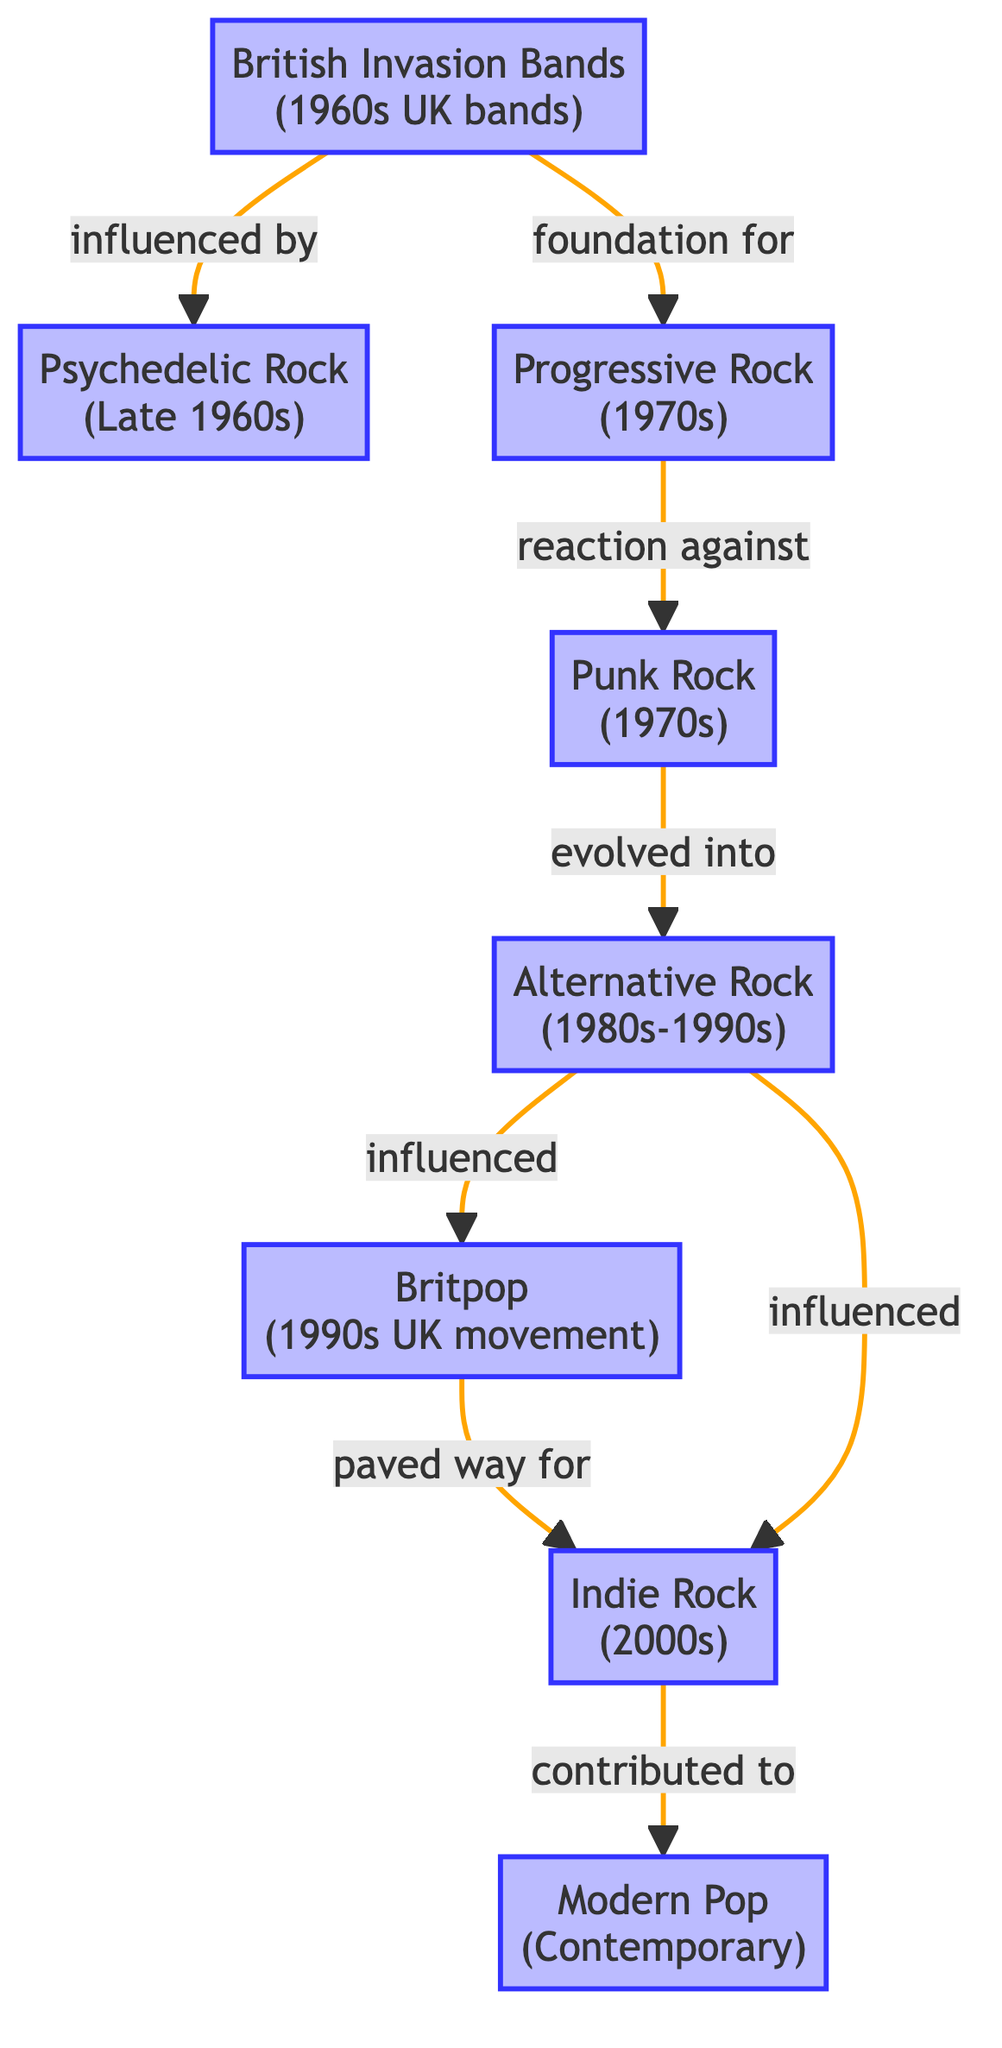What is the first node in the food chain? The first node in the food chain is "British Invasion Bands (1960s UK bands)," which serves as the starting point for the flow of popularity in this diagram.
Answer: British Invasion Bands (1960s UK bands) How many nodes are in the food chain? By counting the nodes listed in the diagram, there are a total of eight nodes representing different musical genres and movements.
Answer: 8 Which genre evolved from Punk Rock? According to the diagram, Alternative Rock is shown as evolving from Punk Rock, indicating a direct relationship in the flow of musical trends.
Answer: Alternative Rock (1980s-1990s) What genre is influenced by Britpop? The diagram indicates that Indie Rock is influenced by Britpop, demonstrating a continuation of musical evolution between these two genres.
Answer: Indie Rock (2000s) Which two genres have a direct link from Alternative Rock? The diagram shows that Alternative Rock has direct links to both Britpop and Indie Rock, indicating its influence on these genres.
Answer: Britpop and Indie Rock What is the relationship between Progressive Rock and Punk Rock? The diagram illustrates that Punk Rock is a reaction against Progressive Rock, showing a critical response in the evolution of music styles.
Answer: Reaction against How many arrows connect to the "Modern Pop" node? There is a single arrow connecting from Indie Rock to Modern Pop, indicating that Indie Rock directly contributes to the sound of contemporary pop music.
Answer: 1 What genre comes directly after Psychedelic Rock in the flow? Following Psychedelic Rock in the diagram is Progressive Rock, which signifies its influence and continuation of musical experimentation.
Answer: Progressive Rock (1970s) Which genre can be traced back to British Invasion Bands through the longest chain of influence? By following the flow of the diagram, one can trace the influence from British Invasion Bands through several genres, culminating in Modern Pop, which represents the furthest evolution of musical trends.
Answer: Modern Pop (Contemporary) 